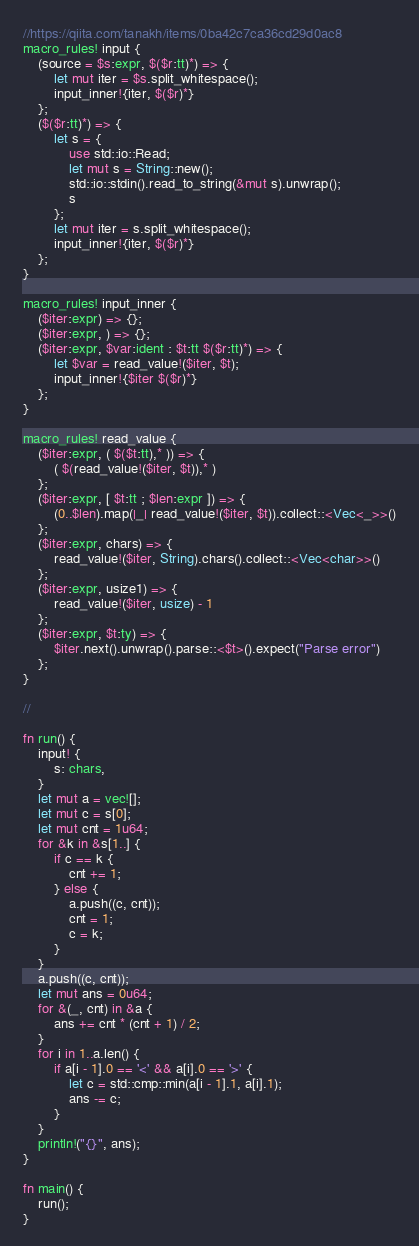Convert code to text. <code><loc_0><loc_0><loc_500><loc_500><_Rust_>//https://qiita.com/tanakh/items/0ba42c7ca36cd29d0ac8
macro_rules! input {
    (source = $s:expr, $($r:tt)*) => {
        let mut iter = $s.split_whitespace();
        input_inner!{iter, $($r)*}
    };
    ($($r:tt)*) => {
        let s = {
            use std::io::Read;
            let mut s = String::new();
            std::io::stdin().read_to_string(&mut s).unwrap();
            s
        };
        let mut iter = s.split_whitespace();
        input_inner!{iter, $($r)*}
    };
}

macro_rules! input_inner {
    ($iter:expr) => {};
    ($iter:expr, ) => {};
    ($iter:expr, $var:ident : $t:tt $($r:tt)*) => {
        let $var = read_value!($iter, $t);
        input_inner!{$iter $($r)*}
    };
}

macro_rules! read_value {
    ($iter:expr, ( $($t:tt),* )) => {
        ( $(read_value!($iter, $t)),* )
    };
    ($iter:expr, [ $t:tt ; $len:expr ]) => {
        (0..$len).map(|_| read_value!($iter, $t)).collect::<Vec<_>>()
    };
    ($iter:expr, chars) => {
        read_value!($iter, String).chars().collect::<Vec<char>>()
    };
    ($iter:expr, usize1) => {
        read_value!($iter, usize) - 1
    };
    ($iter:expr, $t:ty) => {
        $iter.next().unwrap().parse::<$t>().expect("Parse error")
    };
}

//

fn run() {
    input! {
        s: chars,
    }
    let mut a = vec![];
    let mut c = s[0];
    let mut cnt = 1u64;
    for &k in &s[1..] {
        if c == k {
            cnt += 1;
        } else {
            a.push((c, cnt));
            cnt = 1;
            c = k;
        }
    }
    a.push((c, cnt));
    let mut ans = 0u64;
    for &(_, cnt) in &a {
        ans += cnt * (cnt + 1) / 2;
    }
    for i in 1..a.len() {
        if a[i - 1].0 == '<' && a[i].0 == '>' {
            let c = std::cmp::min(a[i - 1].1, a[i].1);
            ans -= c;
        }
    }
    println!("{}", ans);
}

fn main() {
    run();
}
</code> 